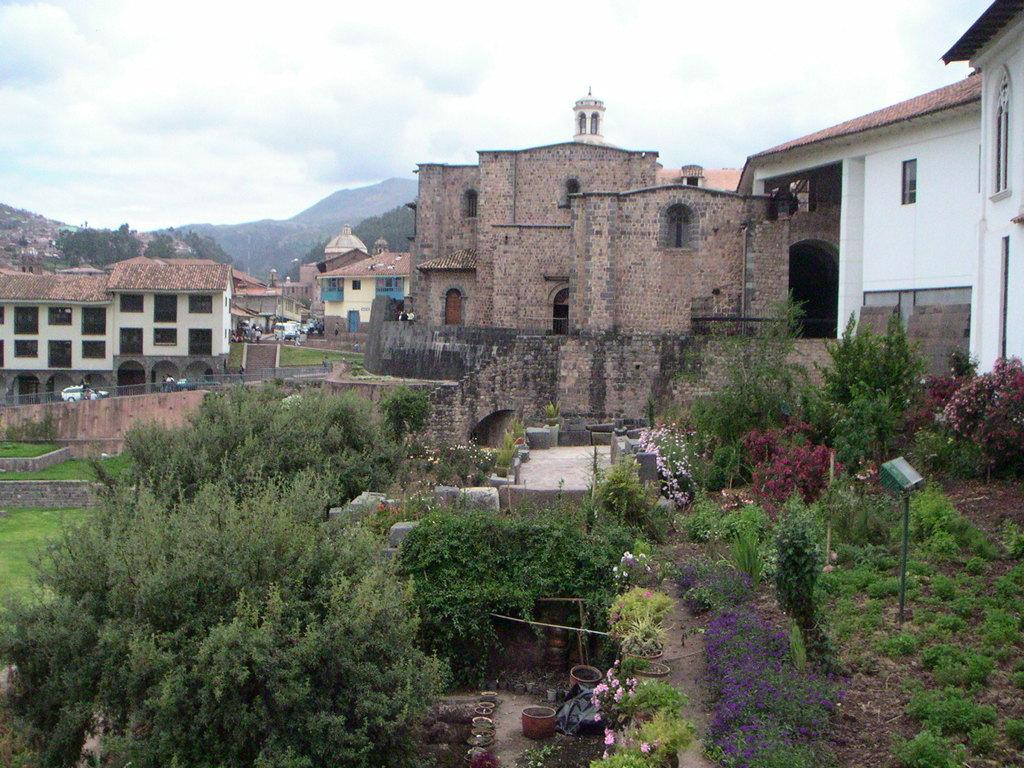What is located in the center of the image? There are trees in the center of the image. What object can be seen in the image besides the trees? There is a pole in the image. What type of vegetation is on the ground in the image? There is grass on the ground. What can be seen in the background of the image? There are buildings, trees, and mountains in the background of the image. What is the condition of the sky in the image? The sky is cloudy in the image. Can you tell me how many knots are tied in the trees in the image? There are no knots present in the trees in the image. What type of salt can be seen sprinkled on the grass in the image? There is no salt present on the grass in the image. 